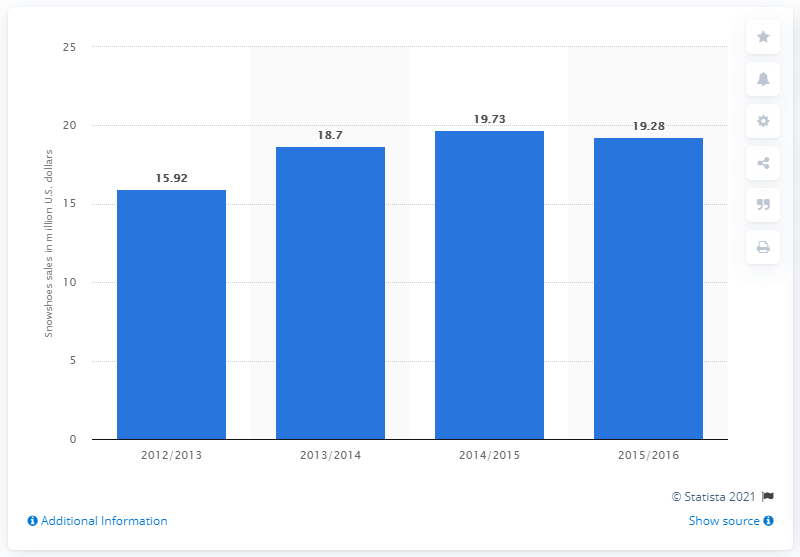Highlight a few significant elements in this photo. In the United States, the sales of snowshoes in the 2015/2016 fiscal year totaled 19.28 million dollars. 